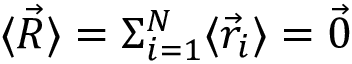<formula> <loc_0><loc_0><loc_500><loc_500>\langle { \vec { R } } \rangle = \Sigma _ { i = 1 } ^ { N } \langle { \vec { r } } _ { i } \rangle = { \vec { 0 } }</formula> 